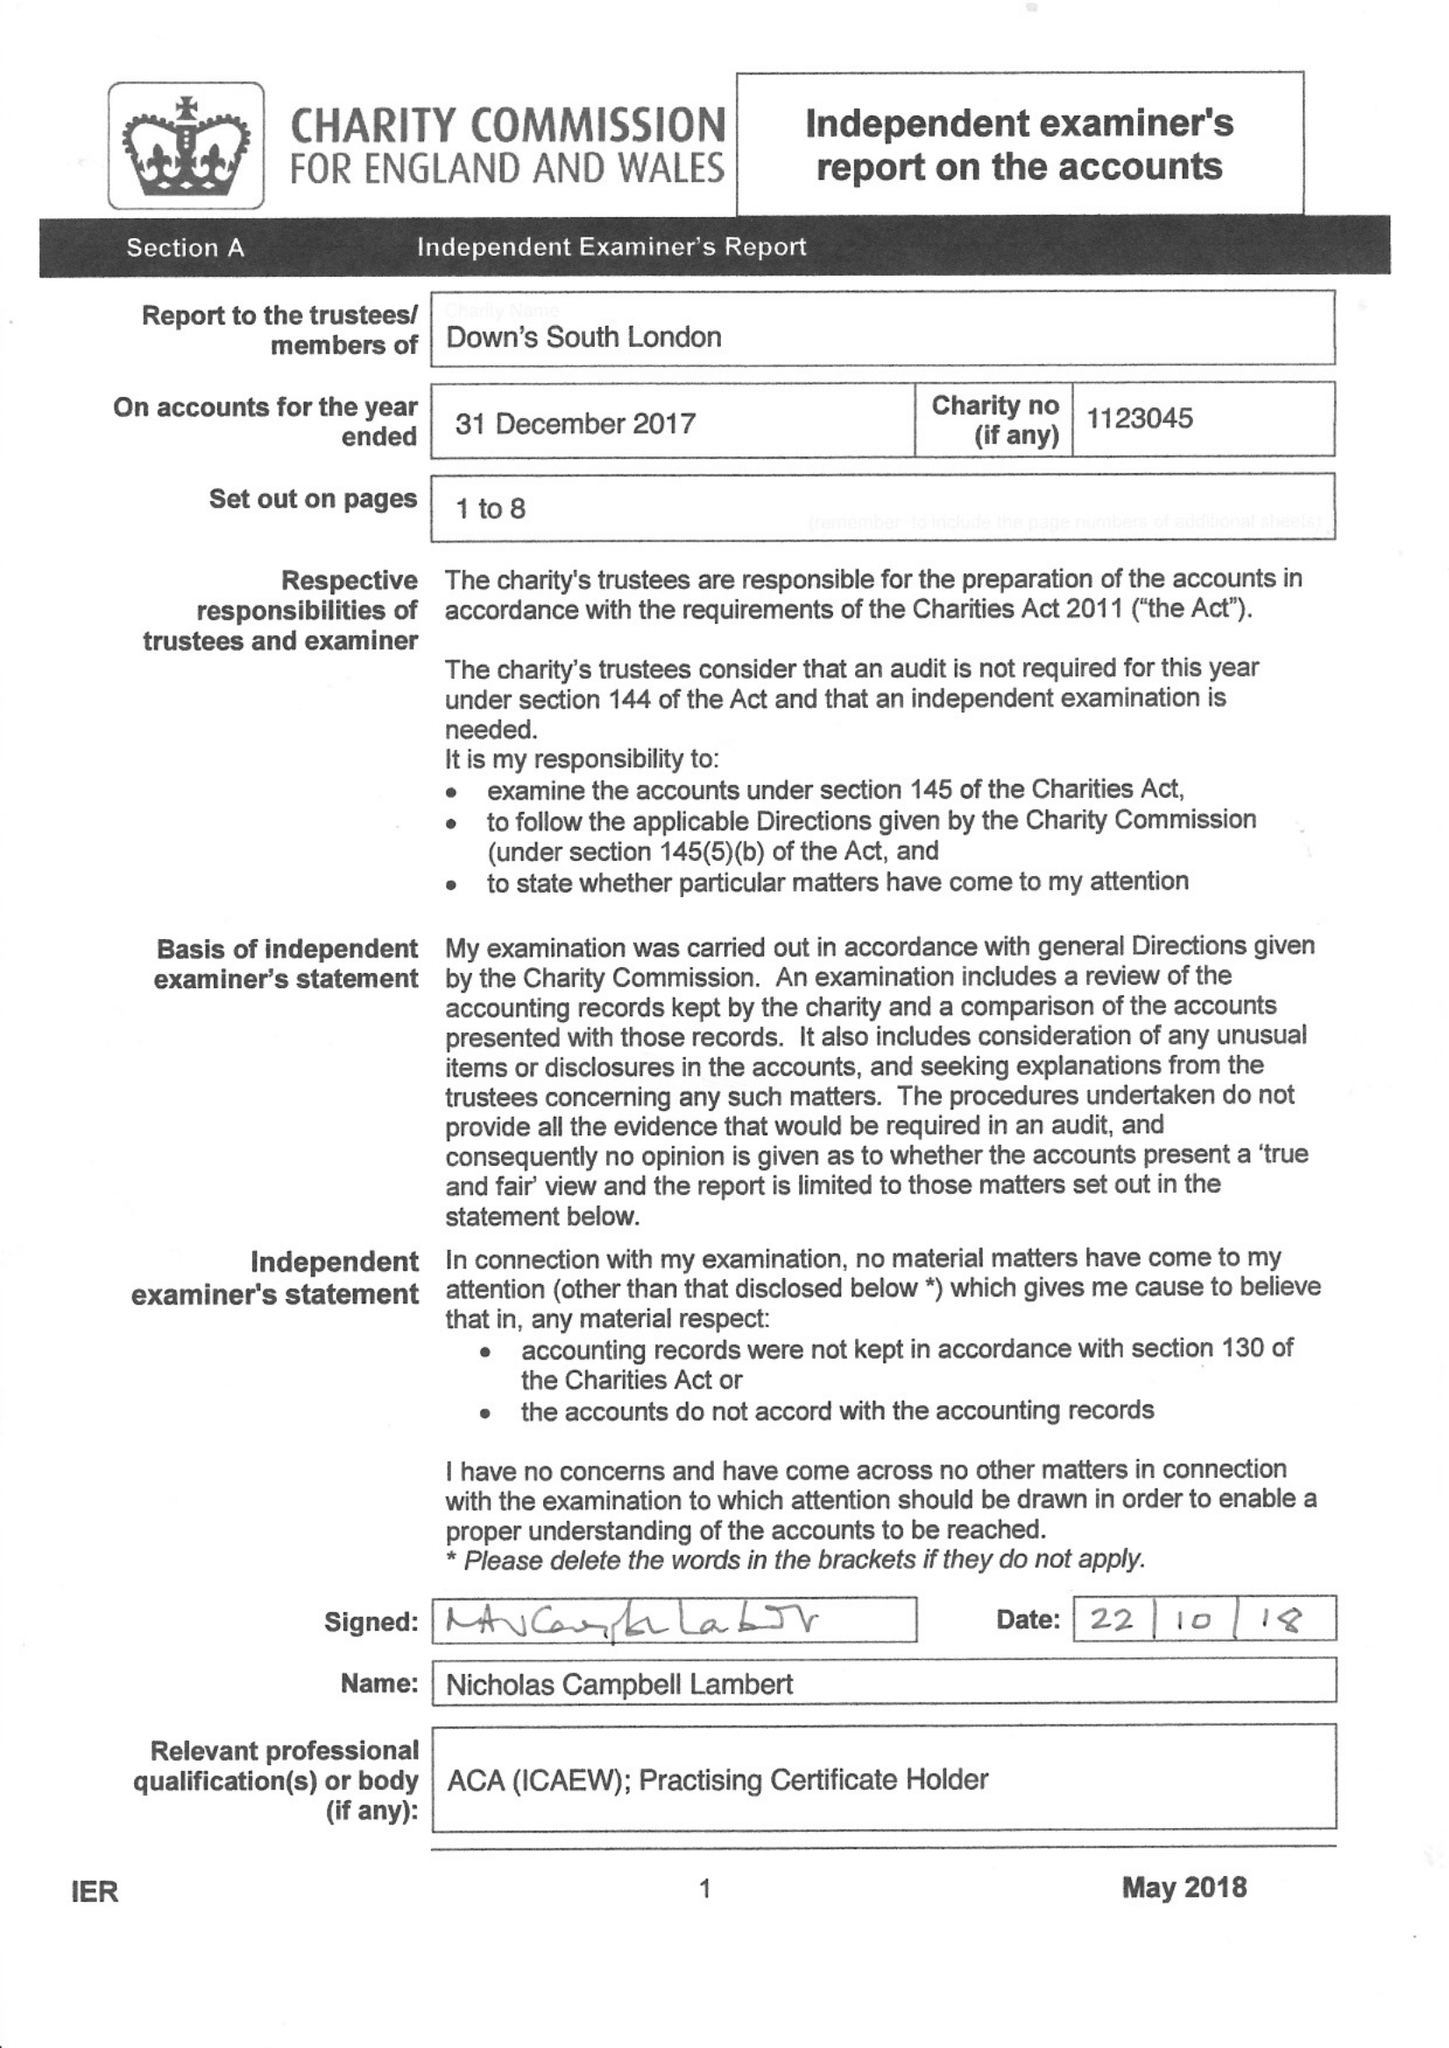What is the value for the report_date?
Answer the question using a single word or phrase. 2017-12-31 